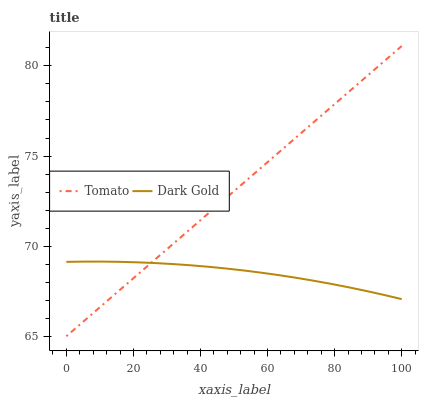Does Dark Gold have the maximum area under the curve?
Answer yes or no. No. Is Dark Gold the smoothest?
Answer yes or no. No. Does Dark Gold have the lowest value?
Answer yes or no. No. Does Dark Gold have the highest value?
Answer yes or no. No. 